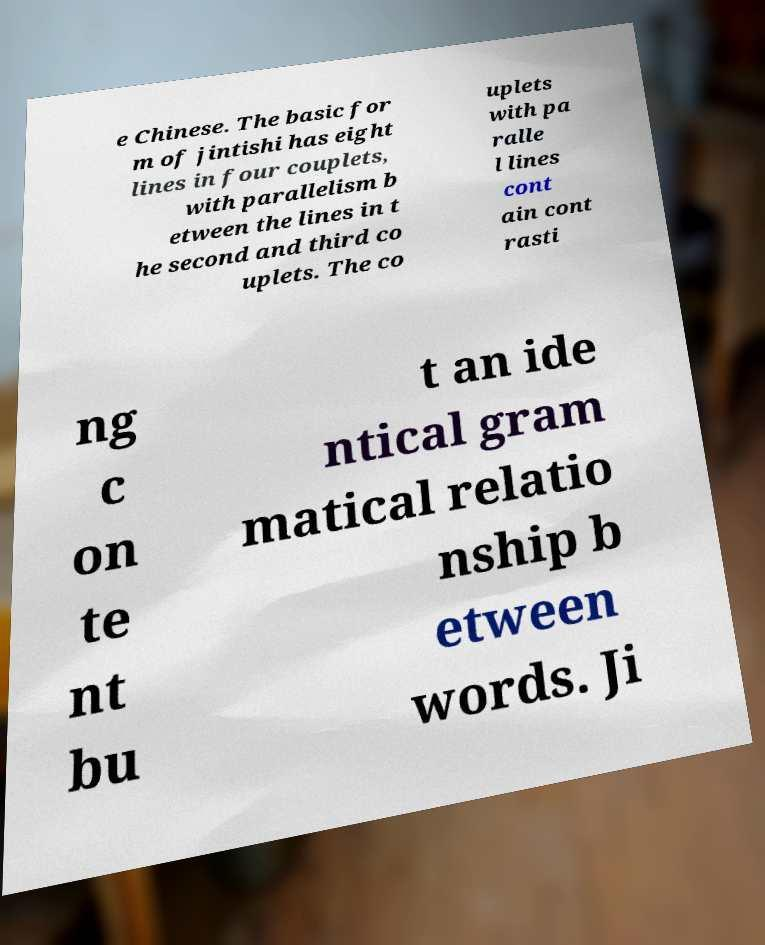Can you accurately transcribe the text from the provided image for me? e Chinese. The basic for m of jintishi has eight lines in four couplets, with parallelism b etween the lines in t he second and third co uplets. The co uplets with pa ralle l lines cont ain cont rasti ng c on te nt bu t an ide ntical gram matical relatio nship b etween words. Ji 